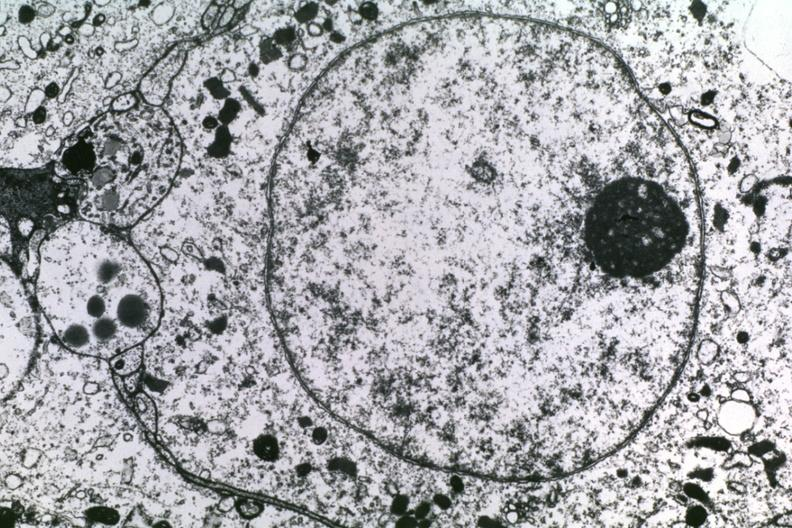does hyperplasia show dr garcia tumors 55?
Answer the question using a single word or phrase. No 